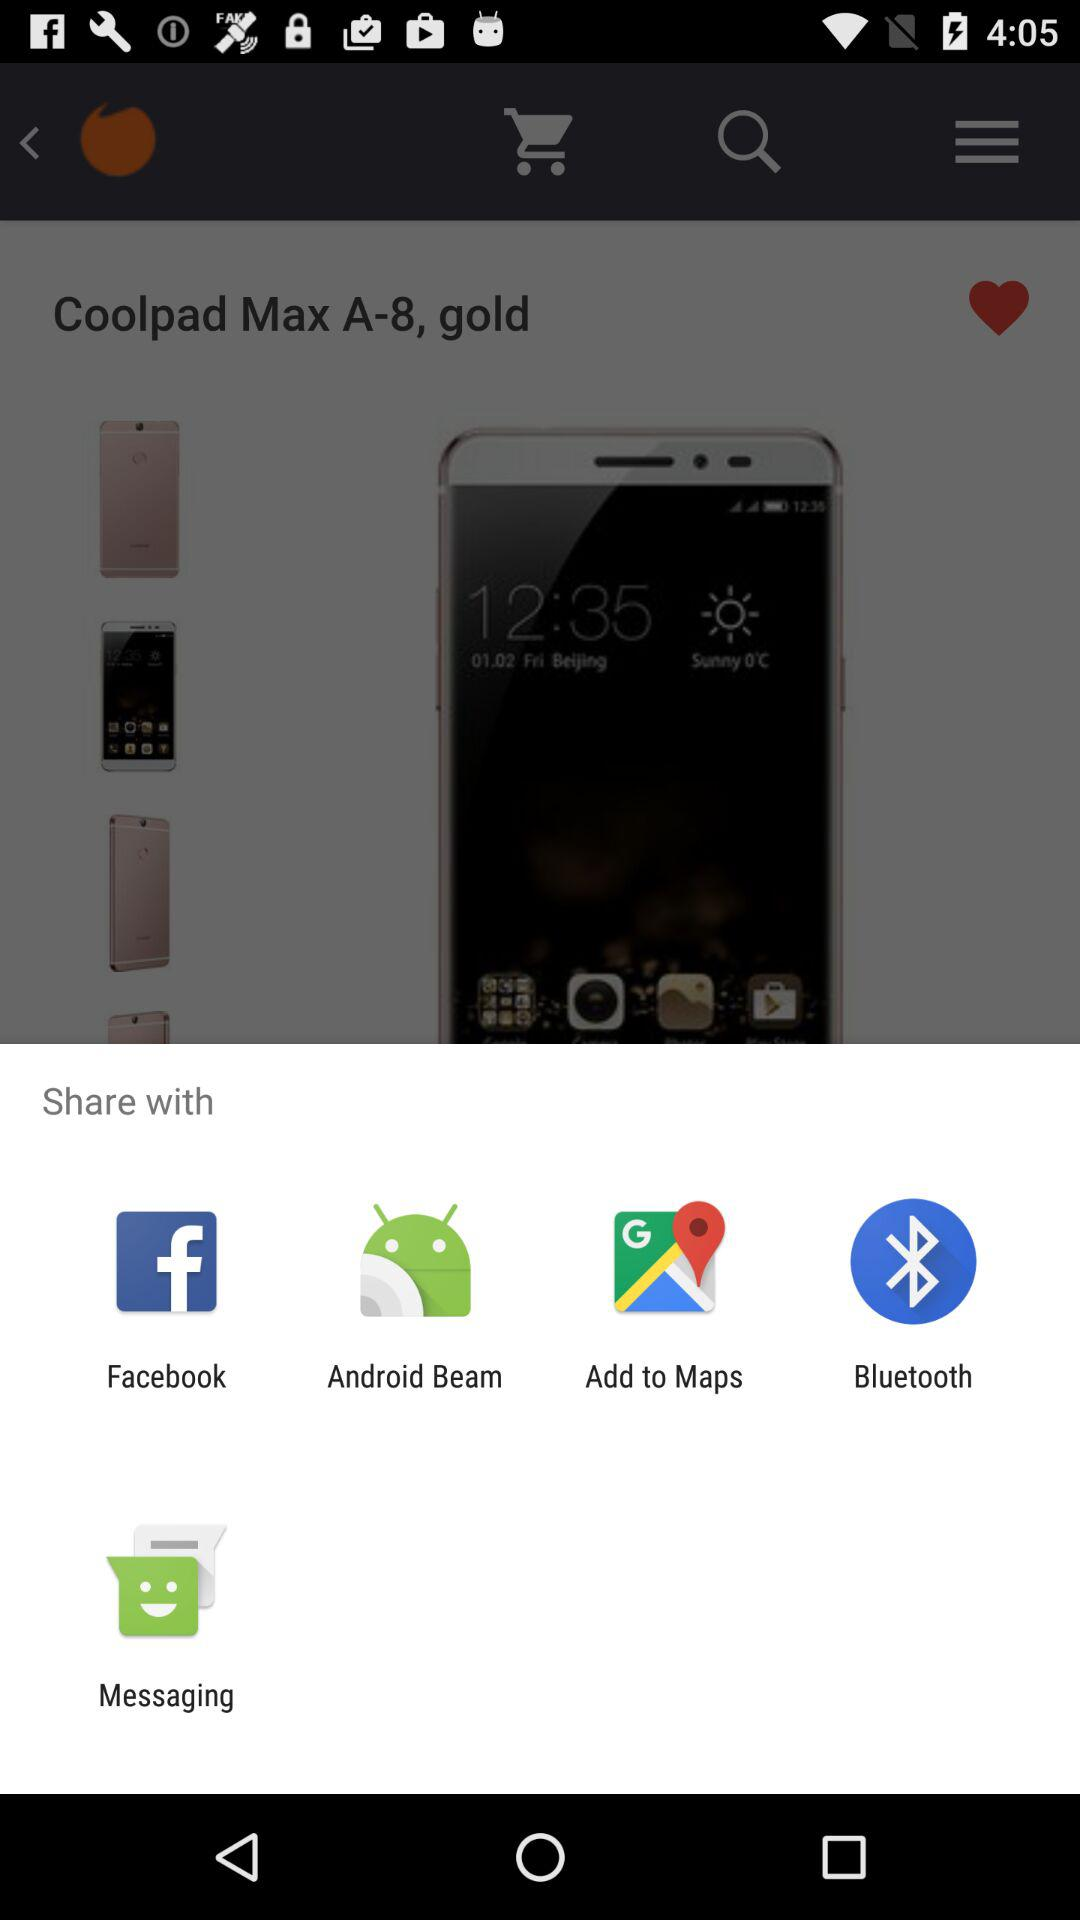What applications can be used to share? The applications that can be used to share are "Facebook", "Android Beam", "Add to Maps", "Bluetooth" and "Messaging". 